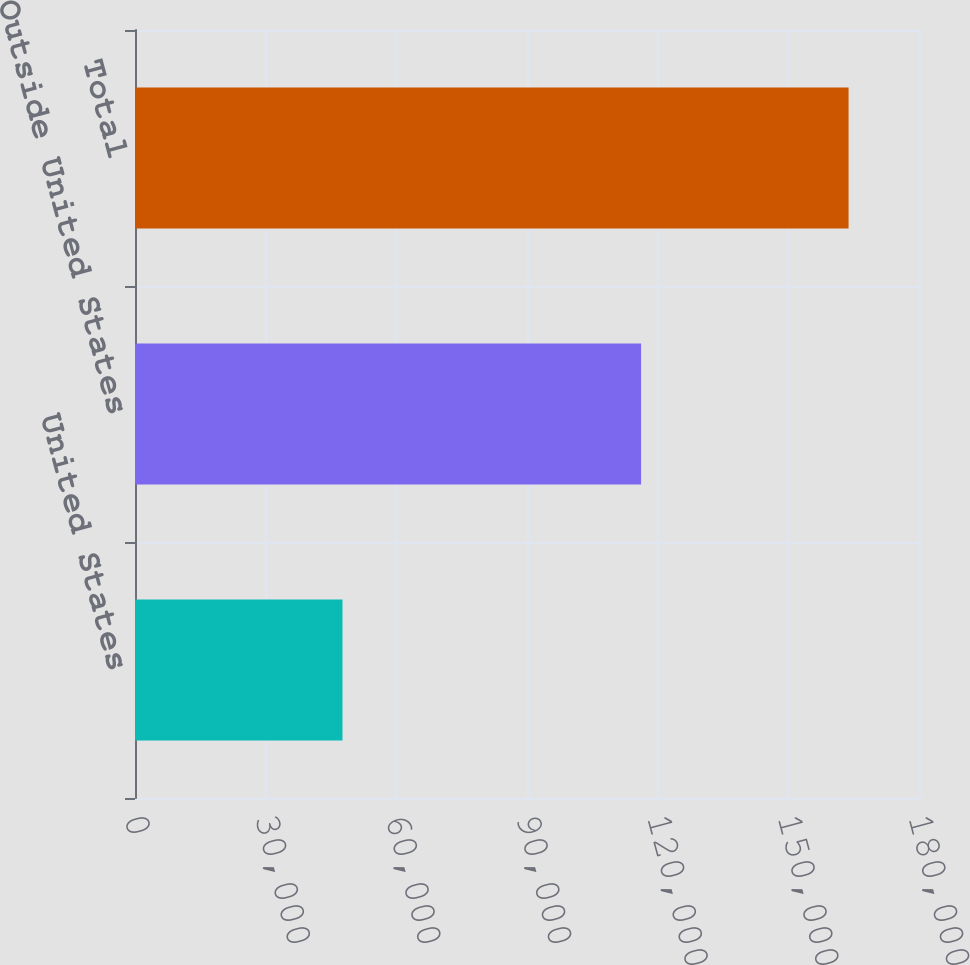<chart> <loc_0><loc_0><loc_500><loc_500><bar_chart><fcel>United States<fcel>Outside United States<fcel>Total<nl><fcel>47636<fcel>116191<fcel>163827<nl></chart> 